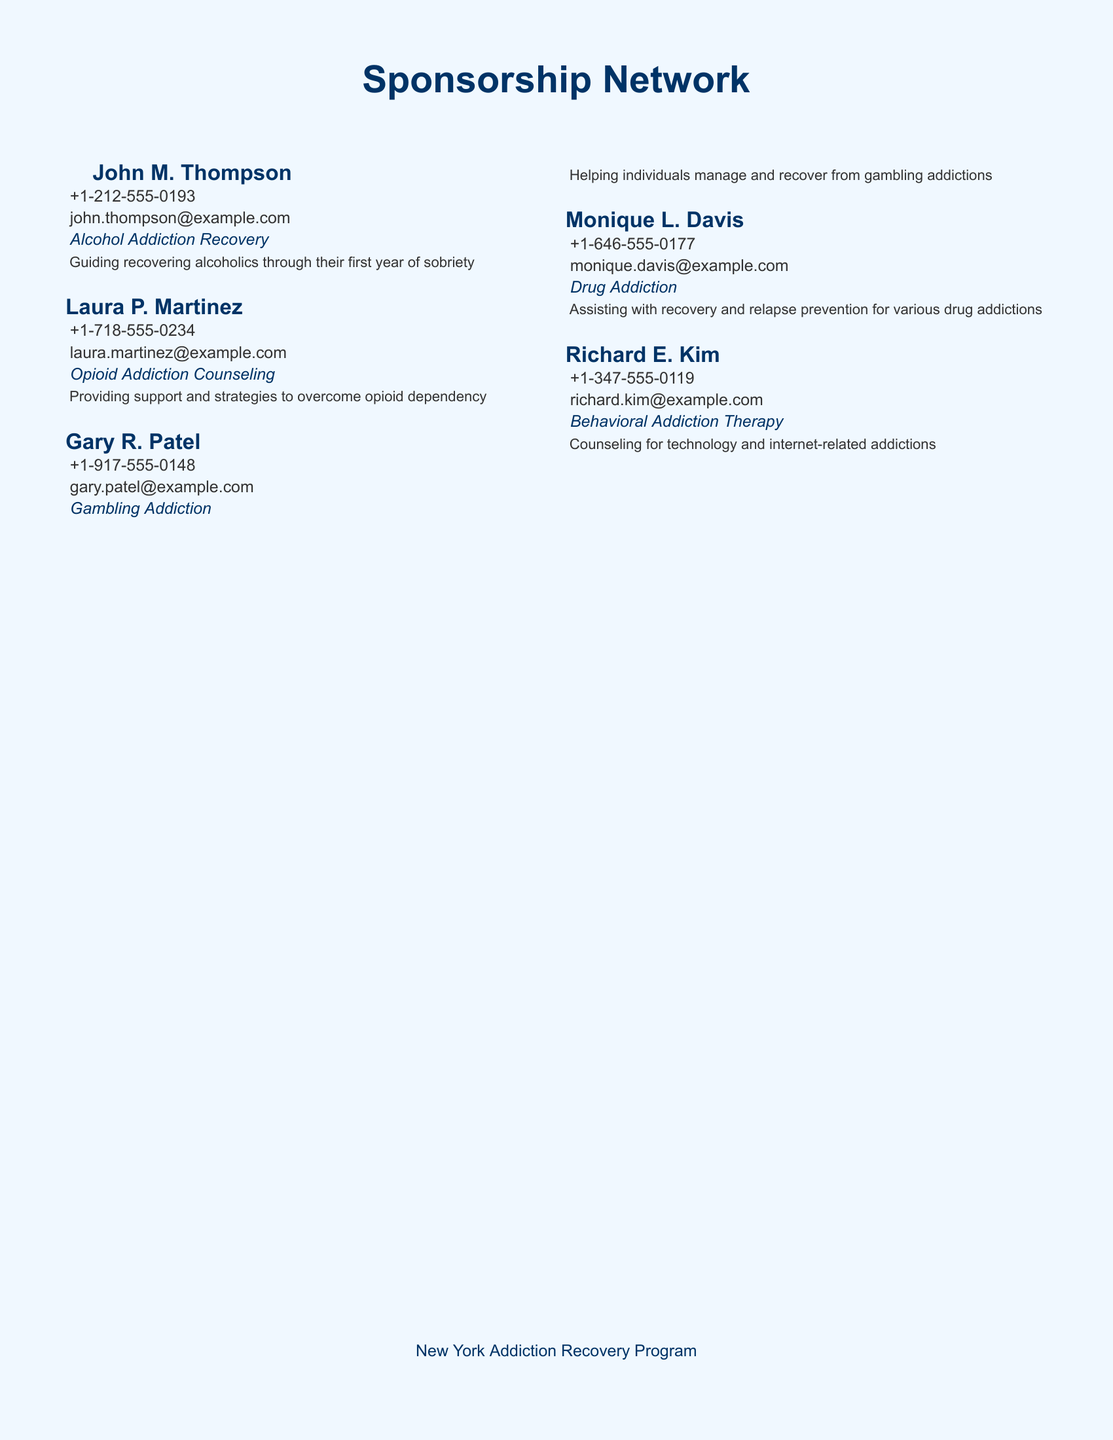What is John M. Thompson's area of expertise? John M. Thompson's area of expertise is listed in the document as "Alcohol Addiction Recovery."
Answer: Alcohol Addiction Recovery What is Laura P. Martinez's contact number? The contact number for Laura P. Martinez is provided in the document as "+1-718-555-0234."
Answer: +1-718-555-0234 Which sponsor specializes in gambling addiction? The document identifies Gary R. Patel as the sponsor who specializes in gambling addiction.
Answer: Gary R. Patel What services does Monique L. Davis offer? The document states that Monique L. Davis assists with recovery and relapse prevention for various drug addictions.
Answer: Assisting with recovery and relapse prevention for various drug addictions How many sponsors are listed in the document? The document lists a total of five sponsors in the Sponsorship Network.
Answer: Five What is Richard E. Kim's email address? Richard E. Kim's email address is included in the document as "richard.kim@example.com."
Answer: richard.kim@example.com Which organization is associated with the Sponsorship Network? The document refers to the "New York Addiction Recovery Program" as the associated organization.
Answer: New York Addiction Recovery Program What type of addiction does Gary R. Patel focus on? According to the document, Gary R. Patel focuses on helping individuals manage and recover from gambling addictions.
Answer: Gambling Addiction Who provides support for opioid dependency? The document mentions Laura P. Martinez as the person providing support for opioid dependency.
Answer: Laura P. Martinez 